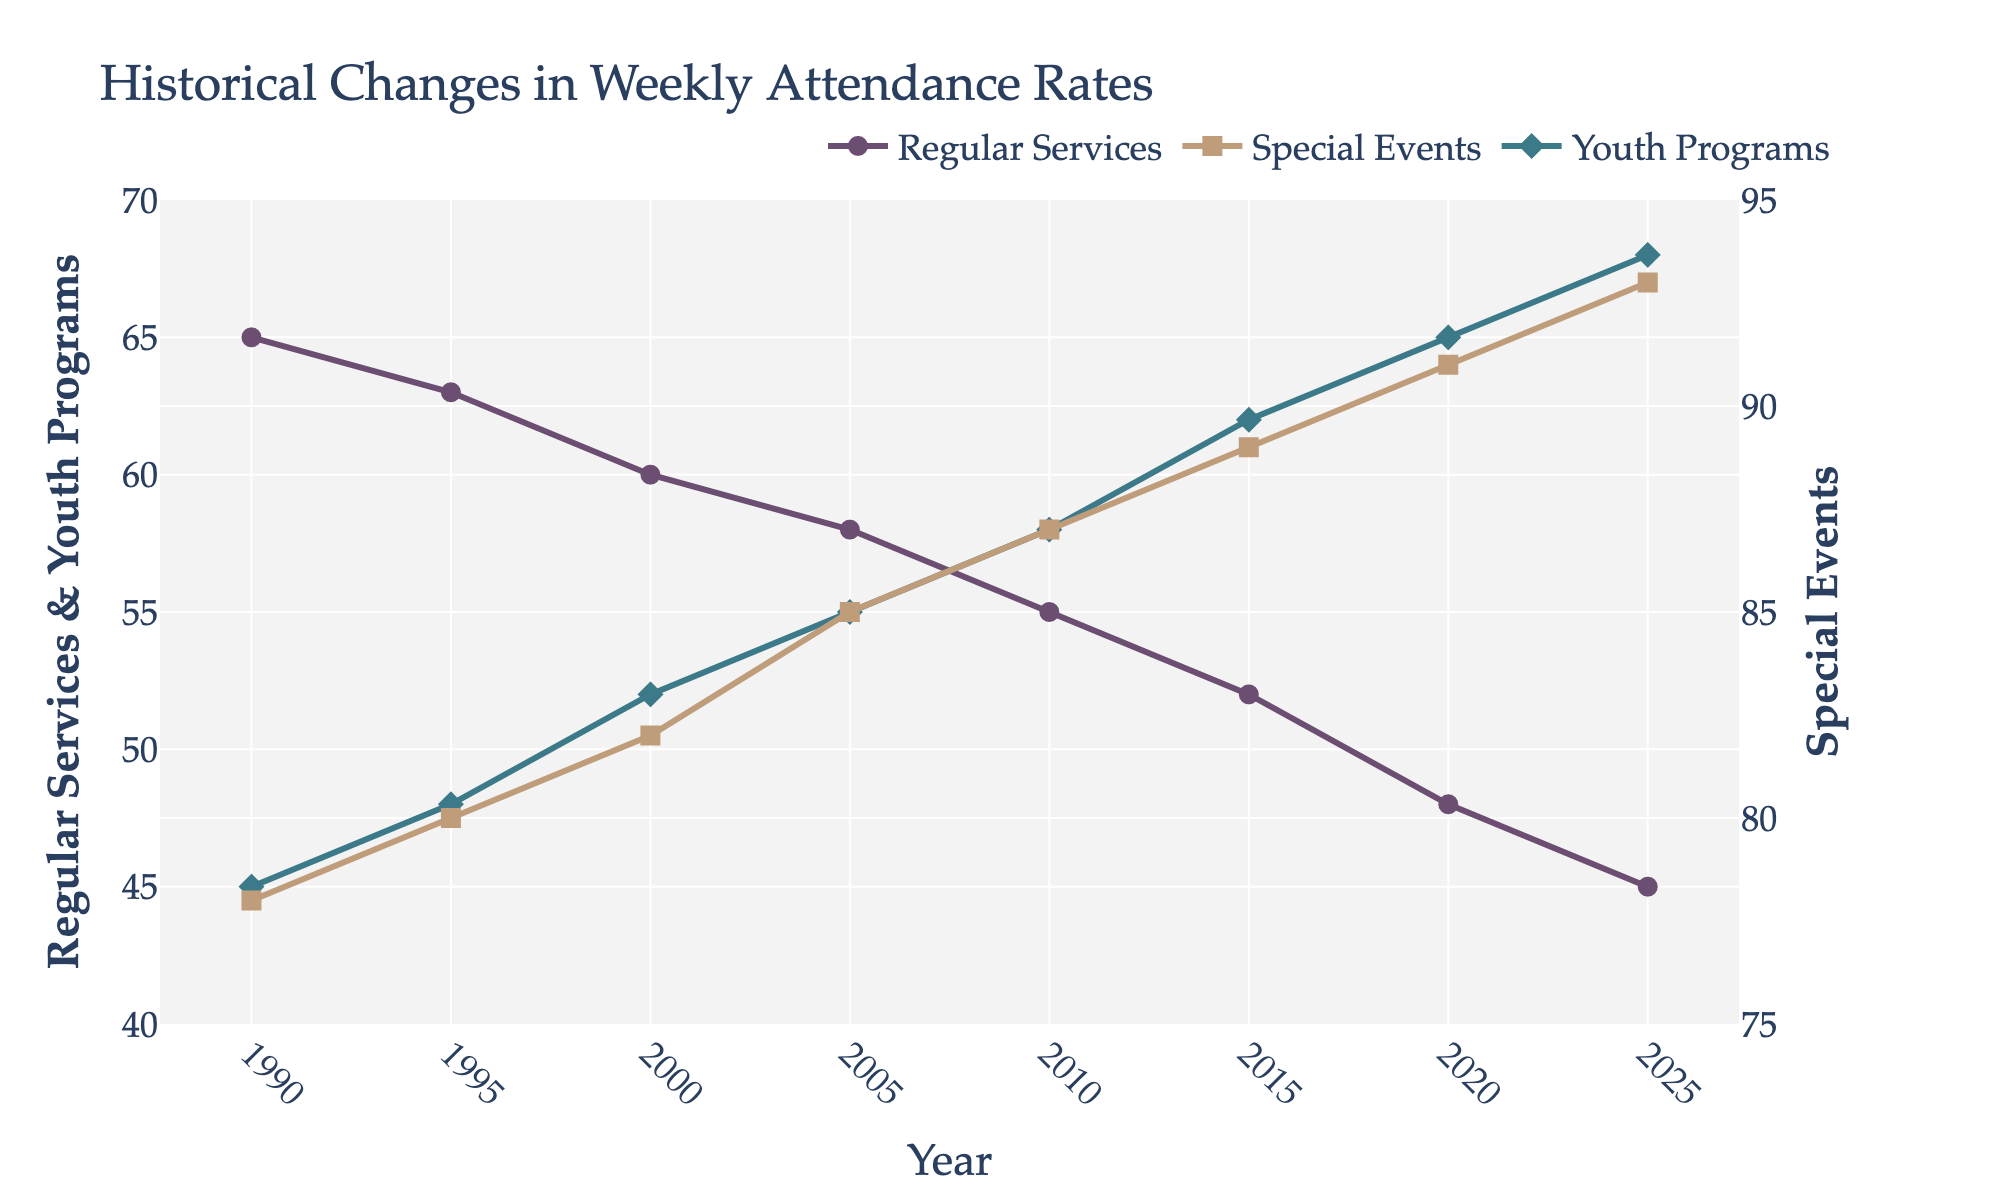What is the general trend in attendance rates for Regular Services from 1990 to 2025? The attendance rate for Regular Services shows a decreasing trend from 65% in 1990 to 45% in 2025.
Answer: Decreasing Which year has the highest attendance for Youth Programs? The highest attendance rate for Youth Programs is in 2025, where it reaches 68%.
Answer: 2025 How does the attendance rate for Special Events in 2010 compare to that in 2000? The attendance rate for Special Events increased from 82% in 2000 to 87% in 2010, showing a 5% increase.
Answer: Increased by 5% By how much did the attendance rate for Regular Services decrease from 1990 to 2025? The attendance rate for Regular Services decreased from 65% in 1990 to 45% in 2025. The decrease is calculated as 65% - 45% = 20%.
Answer: 20% What is the difference in attendance rates between Special Events and Youth Programs in 2020? The attendance rate for Special Events in 2020 is 91%, and for Youth Programs, it is 65%. The difference is 91% - 65% = 26%.
Answer: 26% Which type of service shows the largest increase in attendance rates from 1990 to 2025? Special Events show the largest increase in attendance rates, rising from 78% in 1990 to 93% in 2025, an increase of 15%.
Answer: Special Events Compare the trends of Regular Services and Youth Programs over the years. Regular Services show a declining trend, decreasing from 65% in 1990 to 45% in 2025. In contrast, Youth Programs show an increasing trend, rising from 45% in 1990 to 68% in 2025.
Answer: Opposite trends What is the attendance rate for Regular Services in the year 2000? The attendance rate for Regular Services in the year 2000 is 60%.
Answer: 60% From 1990 to 2010, which service had the greatest overall increase in attendance? From 1990 to 2010, Special Events increased from 78% to 87%, a rise of 9%. Youth Programs increased from 45% to 58%, a rise of 13%. Therefore, Youth Programs had the greatest overall increase.
Answer: Youth Programs 